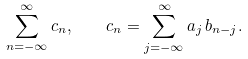<formula> <loc_0><loc_0><loc_500><loc_500>\sum _ { n = - \infty } ^ { \infty } c _ { n } , \quad c _ { n } = \sum _ { j = - \infty } ^ { \infty } a _ { j } \, b _ { n - j } .</formula> 